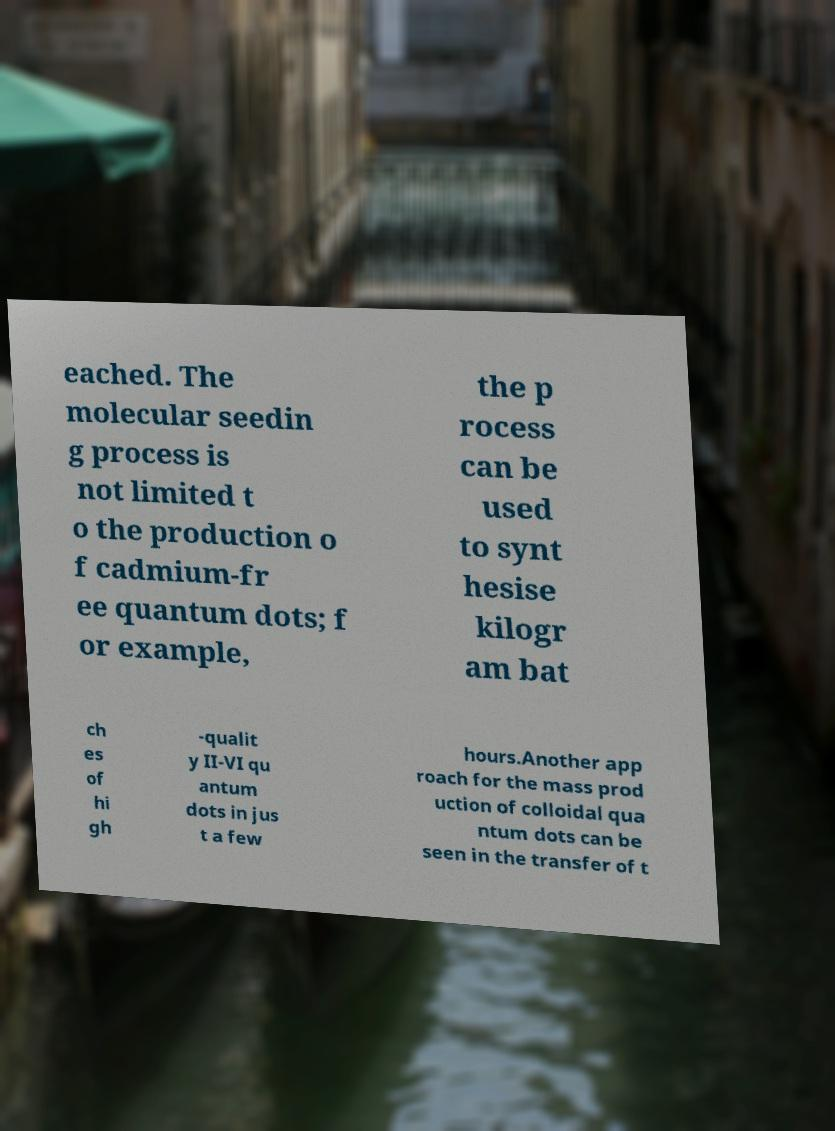There's text embedded in this image that I need extracted. Can you transcribe it verbatim? eached. The molecular seedin g process is not limited t o the production o f cadmium-fr ee quantum dots; f or example, the p rocess can be used to synt hesise kilogr am bat ch es of hi gh -qualit y II-VI qu antum dots in jus t a few hours.Another app roach for the mass prod uction of colloidal qua ntum dots can be seen in the transfer of t 